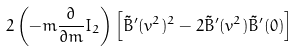Convert formula to latex. <formula><loc_0><loc_0><loc_500><loc_500>2 \left ( - m \frac { \partial } { \partial m } I _ { 2 } \right ) \left [ \tilde { B } ^ { \prime } ( v ^ { 2 } ) ^ { 2 } - 2 \tilde { B } ^ { \prime } ( v ^ { 2 } ) \tilde { B } ^ { \prime } ( 0 ) \right ]</formula> 